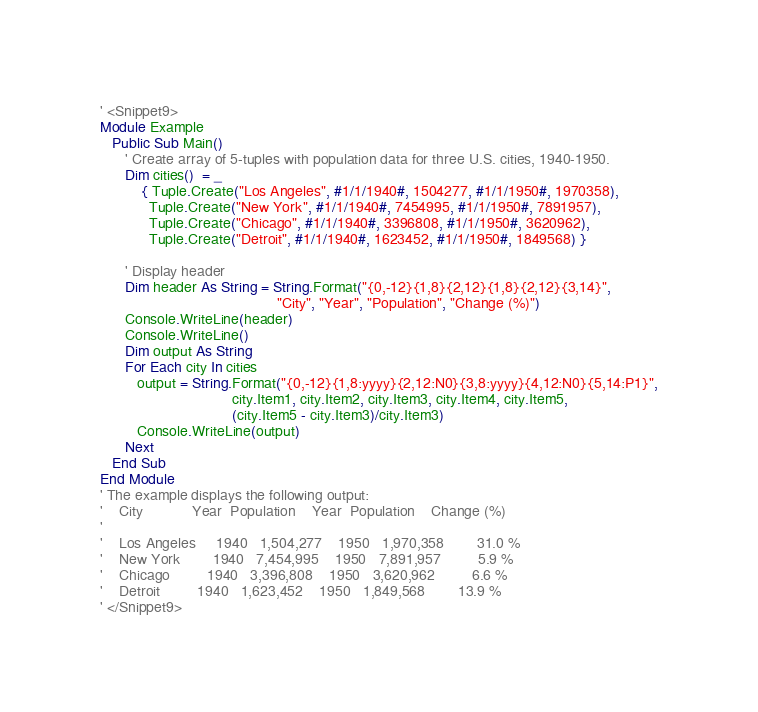<code> <loc_0><loc_0><loc_500><loc_500><_VisualBasic_>
' <Snippet9>
Module Example
   Public Sub Main()
      ' Create array of 5-tuples with population data for three U.S. cities, 1940-1950.
      Dim cities()  = _
          { Tuple.Create("Los Angeles", #1/1/1940#, 1504277, #1/1/1950#, 1970358),
            Tuple.Create("New York", #1/1/1940#, 7454995, #1/1/1950#, 7891957),  
            Tuple.Create("Chicago", #1/1/1940#, 3396808, #1/1/1950#, 3620962),  
            Tuple.Create("Detroit", #1/1/1940#, 1623452, #1/1/1950#, 1849568) }

      ' Display header
      Dim header As String = String.Format("{0,-12}{1,8}{2,12}{1,8}{2,12}{3,14}",
                                           "City", "Year", "Population", "Change (%)")
      Console.WriteLine(header)
      Console.WriteLine()
      Dim output As String      
      For Each city In cities
         output = String.Format("{0,-12}{1,8:yyyy}{2,12:N0}{3,8:yyyy}{4,12:N0}{5,14:P1}",
                                city.Item1, city.Item2, city.Item3, city.Item4, city.Item5,
                                (city.Item5 - city.Item3)/city.Item3)
         Console.WriteLine(output)
      Next
   End Sub
End Module
' The example displays the following output:
'    City            Year  Population    Year  Population    Change (%)
'    
'    Los Angeles     1940   1,504,277    1950   1,970,358        31.0 %
'    New York        1940   7,454,995    1950   7,891,957         5.9 %
'    Chicago         1940   3,396,808    1950   3,620,962         6.6 %
'    Detroit         1940   1,623,452    1950   1,849,568        13.9 %
' </Snippet9>
</code> 